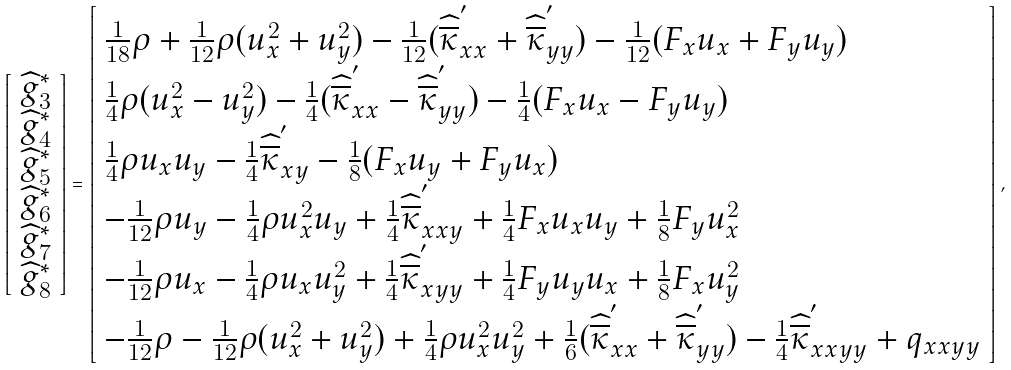<formula> <loc_0><loc_0><loc_500><loc_500>\left [ \begin{array} { l } { \widehat { g } _ { 3 } ^ { * } } \\ { \widehat { g } _ { 4 } ^ { * } } \\ { \widehat { g } _ { 5 } ^ { * } } \\ { \widehat { g } _ { 6 } ^ { * } } \\ { \widehat { g } _ { 7 } ^ { * } } \\ { \widehat { g } _ { 8 } ^ { * } } \end{array} \right ] = \left [ \begin{array} { l } { \frac { 1 } { 1 8 } \rho + \frac { 1 } { 1 2 } \rho ( u _ { x } ^ { 2 } + u _ { y } ^ { 2 } ) - \frac { 1 } { 1 2 } ( \widehat { \overline { \kappa } } _ { x x } ^ { ^ { \prime } } + \widehat { \overline { \kappa } } _ { y y } ^ { ^ { \prime } } ) - \frac { 1 } { 1 2 } ( F _ { x } u _ { x } + F _ { y } u _ { y } ) } \\ { \frac { 1 } { 4 } \rho ( u _ { x } ^ { 2 } - u _ { y } ^ { 2 } ) - \frac { 1 } { 4 } ( \widehat { \overline { \kappa } } _ { x x } ^ { ^ { \prime } } - \widehat { \overline { \kappa } } _ { y y } ^ { ^ { \prime } } ) - \frac { 1 } { 4 } ( F _ { x } u _ { x } - F _ { y } u _ { y } ) } \\ { \frac { 1 } { 4 } \rho u _ { x } u _ { y } - \frac { 1 } { 4 } \widehat { \overline { \kappa } } _ { x y } ^ { ^ { \prime } } - \frac { 1 } { 8 } ( F _ { x } u _ { y } + F _ { y } u _ { x } ) } \\ { - \frac { 1 } { 1 2 } \rho u _ { y } - \frac { 1 } { 4 } \rho u _ { x } ^ { 2 } u _ { y } + \frac { 1 } { 4 } \widehat { \overline { \kappa } } _ { x x y } ^ { ^ { \prime } } + \frac { 1 } { 4 } F _ { x } u _ { x } u _ { y } + \frac { 1 } { 8 } F _ { y } u _ { x } ^ { 2 } } \\ { - \frac { 1 } { 1 2 } \rho u _ { x } - \frac { 1 } { 4 } \rho u _ { x } u _ { y } ^ { 2 } + \frac { 1 } { 4 } \widehat { \overline { \kappa } } _ { x y y } ^ { ^ { \prime } } + \frac { 1 } { 4 } F _ { y } u _ { y } u _ { x } + \frac { 1 } { 8 } F _ { x } u _ { y } ^ { 2 } } \\ { - \frac { 1 } { 1 2 } \rho - \frac { 1 } { 1 2 } \rho ( u _ { x } ^ { 2 } + u _ { y } ^ { 2 } ) + \frac { 1 } { 4 } \rho u _ { x } ^ { 2 } u _ { y } ^ { 2 } + \frac { 1 } { 6 } ( \widehat { \overline { \kappa } } _ { x x } ^ { ^ { \prime } } + \widehat { \overline { \kappa } } _ { y y } ^ { ^ { \prime } } ) - \frac { 1 } { 4 } \widehat { \overline { \kappa } } _ { x x y y } ^ { ^ { \prime } } + q _ { x x y y } } \end{array} \right ] ,</formula> 